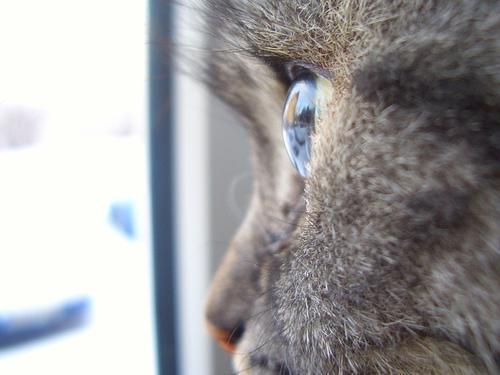How many zebras are facing the camera?
Give a very brief answer. 0. 